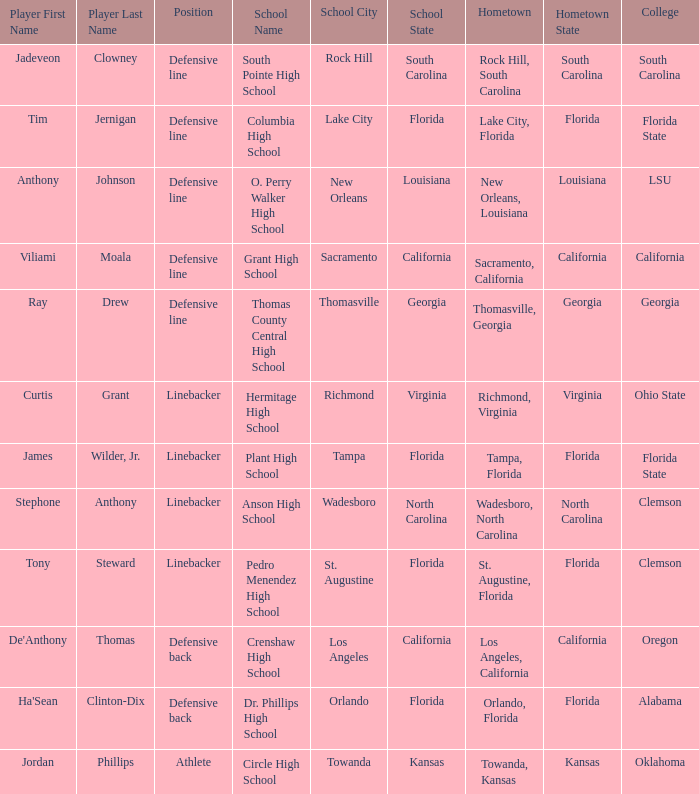Which college is Jordan Phillips playing for? Oklahoma. 